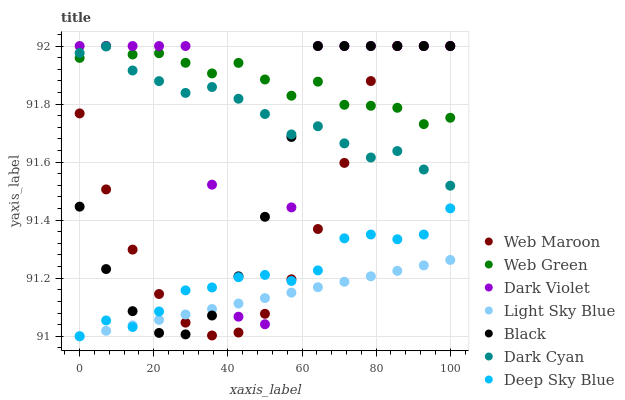Does Light Sky Blue have the minimum area under the curve?
Answer yes or no. Yes. Does Web Green have the maximum area under the curve?
Answer yes or no. Yes. Does Dark Violet have the minimum area under the curve?
Answer yes or no. No. Does Dark Violet have the maximum area under the curve?
Answer yes or no. No. Is Light Sky Blue the smoothest?
Answer yes or no. Yes. Is Dark Violet the roughest?
Answer yes or no. Yes. Is Dark Violet the smoothest?
Answer yes or no. No. Is Light Sky Blue the roughest?
Answer yes or no. No. Does Light Sky Blue have the lowest value?
Answer yes or no. Yes. Does Dark Violet have the lowest value?
Answer yes or no. No. Does Web Green have the highest value?
Answer yes or no. Yes. Does Light Sky Blue have the highest value?
Answer yes or no. No. Is Light Sky Blue less than Dark Cyan?
Answer yes or no. Yes. Is Web Green greater than Deep Sky Blue?
Answer yes or no. Yes. Does Web Maroon intersect Light Sky Blue?
Answer yes or no. Yes. Is Web Maroon less than Light Sky Blue?
Answer yes or no. No. Is Web Maroon greater than Light Sky Blue?
Answer yes or no. No. Does Light Sky Blue intersect Dark Cyan?
Answer yes or no. No. 